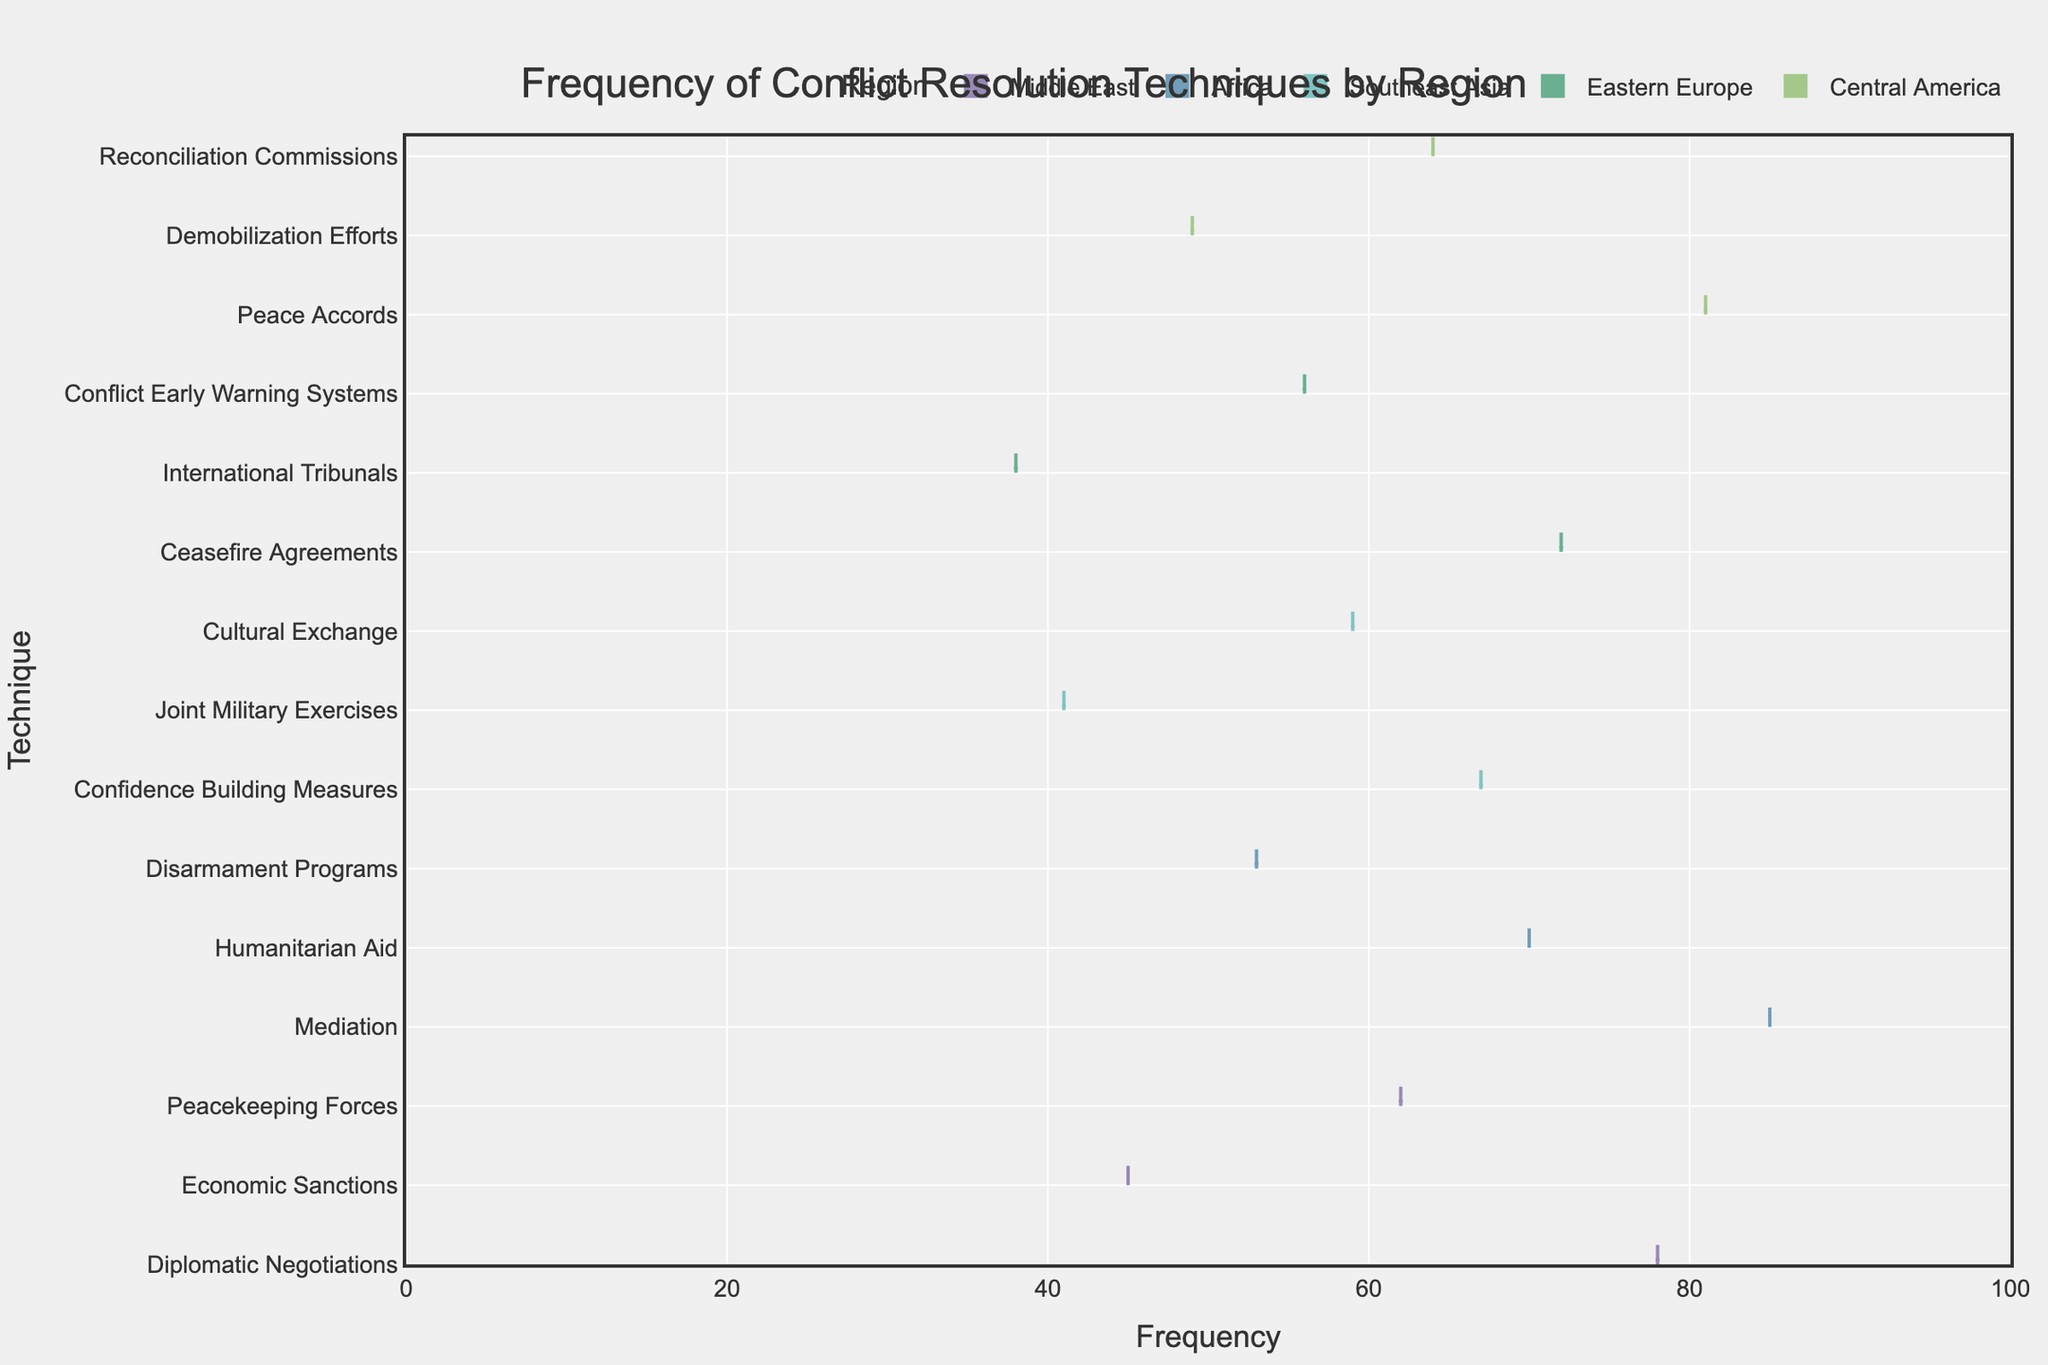What's the title of the figure? The title of the figure is located at the top and generally provides a summary of what the figure represents. In this case, the title is "Frequency of Conflict Resolution Techniques by Region."
Answer: Frequency of Conflict Resolution Techniques by Region What is the range of the x-axis? The x-axis displays the range of frequencies for the conflict resolution techniques. By observing the axis, we can see that it ranges from 0 to 100.
Answer: 0 to 100 Which region used Diplomatic Negotiations the most frequently? Look for the Diplomatic Negotiations technique on the y-axis and trace it horizontally until you find the corresponding region. The region listed with the highest frequency for that technique is the Middle East, with a value of 78.
Answer: Middle East How many techniques were evaluated in the Central America region? Look at the techniques listed under Central America on the y-axis. By counting them, we see three techniques: Peace Accords, Demobilization Efforts, and Reconciliation Commissions.
Answer: 3 Which technique in the Southeast Asia region has the lowest frequency? Identify the techniques in the Southeast Asia region and compare their frequencies. Joint Military Exercises has the lowest frequency with a value of 41.
Answer: Joint Military Exercises What is the average frequency of the techniques used in Africa? Add up the frequencies of the techniques in Africa (Mediation: 85, Humanitarian Aid: 70, Disarmament Programs: 53) and divide by the number of techniques (3). The calculation is (85 + 70 + 53) / 3 = 208 / 3 ≈ 69.33.
Answer: 69.33 Which region has the most balanced (equal) use of all its techniques? Look at the length of the violin plots for each region and assess the spread of frequencies. The region with the most similar lengths (or smallest variance) in its techniques would be considered most balanced. Central America appears most balanced with frequencies of 81, 49, and 64.
Answer: Central America Is the use of mediation in Africa more frequent than ceasefire agreements in Eastern Europe? Compare the frequency values for Mediation in Africa (85) and Ceasefire Agreements in Eastern Europe (72). Since 85 is greater than 72, Mediation in Africa is more frequent.
Answer: Yes What's the technique with the highest frequency in the figure and which region does it belong to? Scan the frequency values for all techniques across regions. The highest frequency is 85 for Mediation in Africa.
Answer: Mediation in Africa 